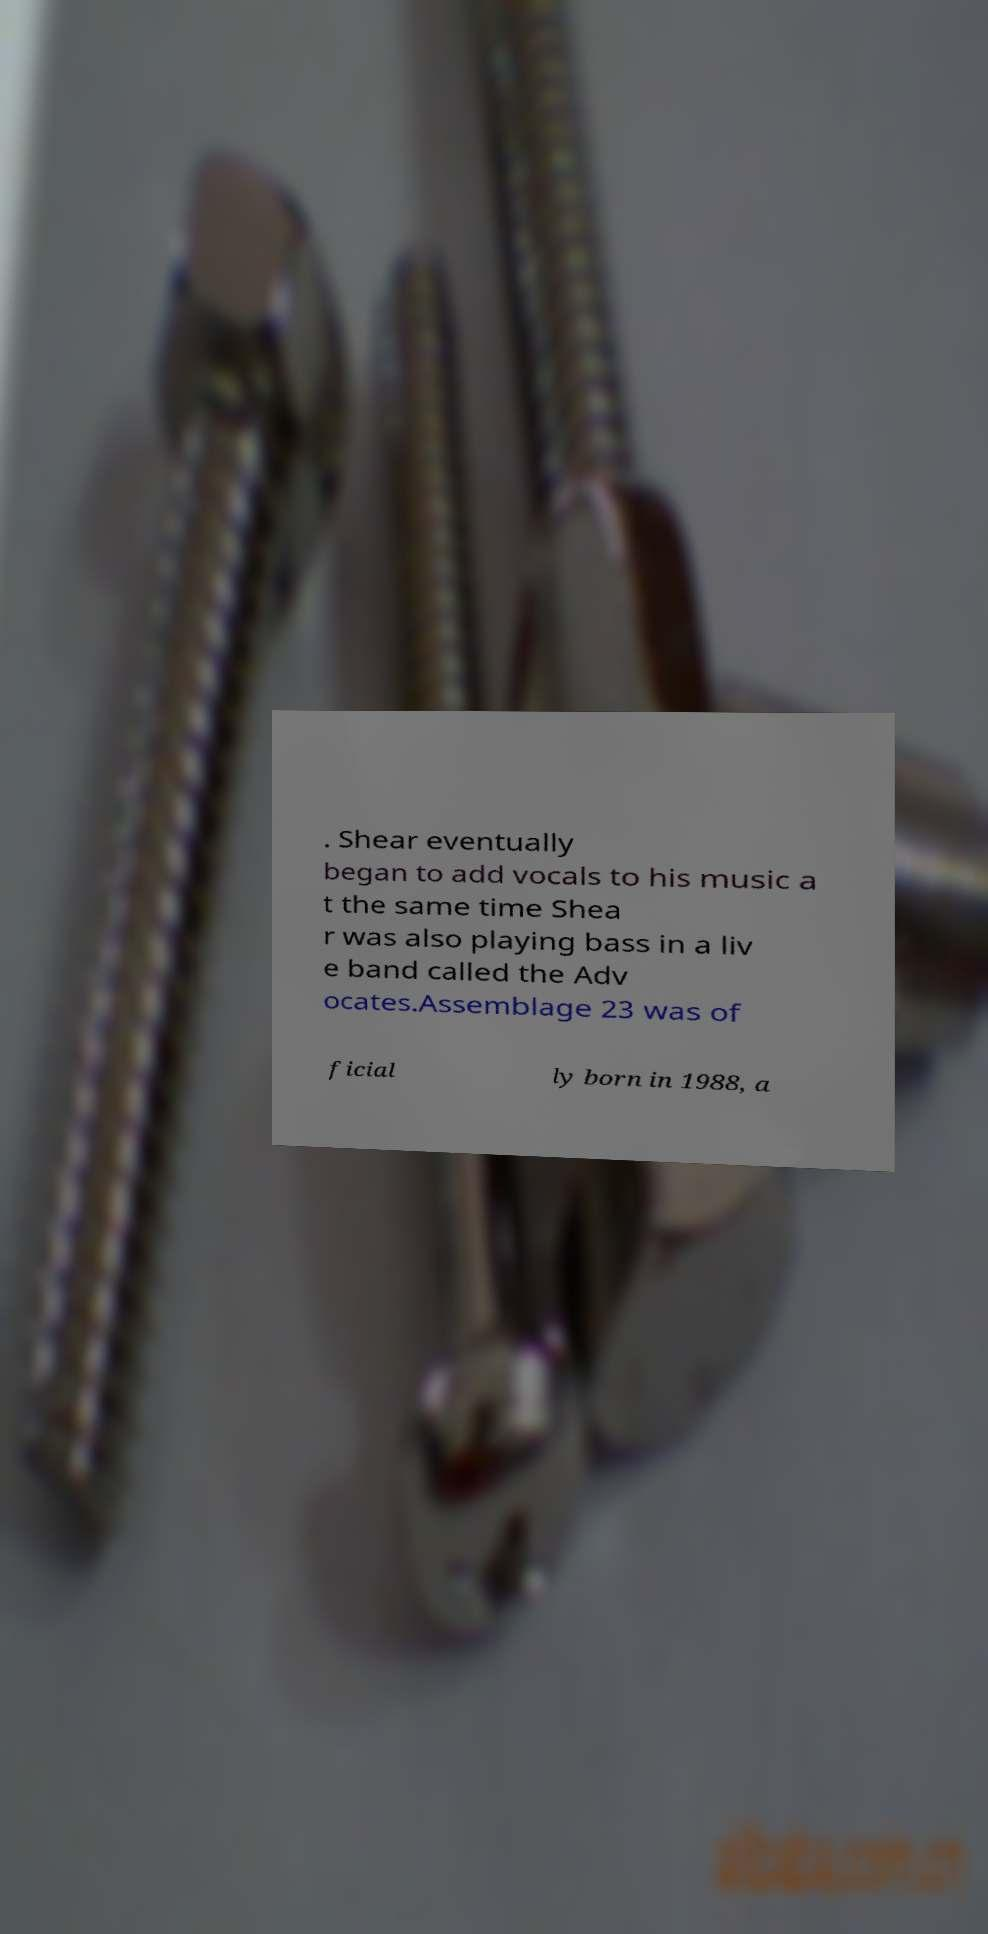What messages or text are displayed in this image? I need them in a readable, typed format. . Shear eventually began to add vocals to his music a t the same time Shea r was also playing bass in a liv e band called the Adv ocates.Assemblage 23 was of ficial ly born in 1988, a 